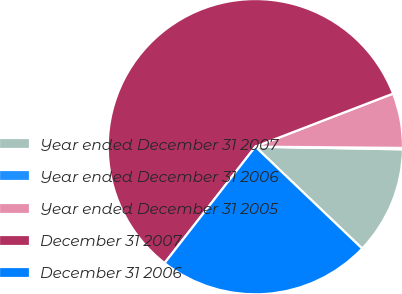<chart> <loc_0><loc_0><loc_500><loc_500><pie_chart><fcel>Year ended December 31 2007<fcel>Year ended December 31 2006<fcel>Year ended December 31 2005<fcel>December 31 2007<fcel>December 31 2006<nl><fcel>11.84%<fcel>0.15%<fcel>5.99%<fcel>58.61%<fcel>23.42%<nl></chart> 